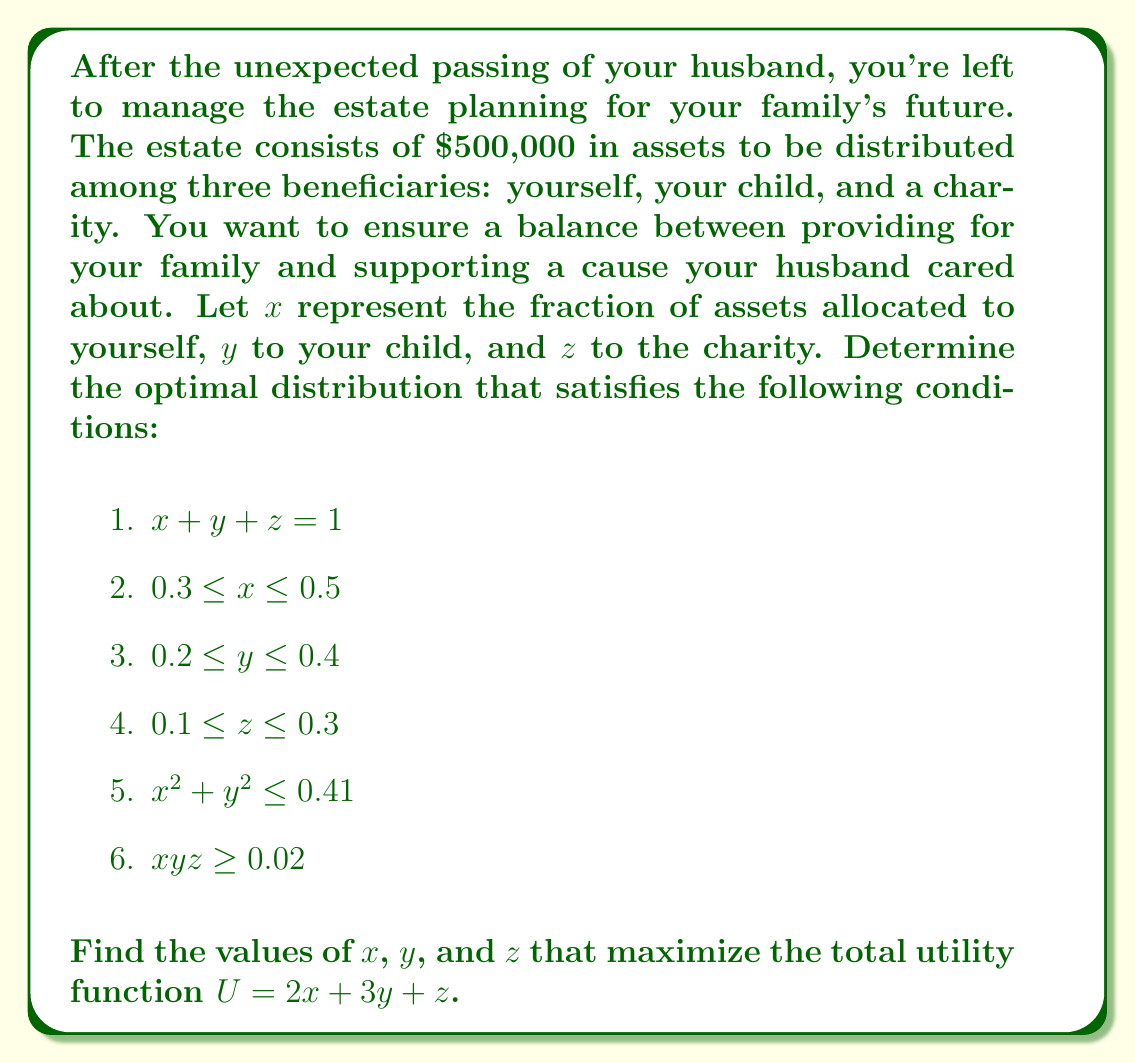Could you help me with this problem? To solve this problem, we'll use the method of constrained optimization with polynomial inequalities:

1) First, we note that the objective function to maximize is $U = 2x + 3y + z$.

2) The constraints form a feasible region in 3D space. We need to find the point in this region that maximizes $U$.

3) The constraint $x + y + z = 1$ allows us to eliminate one variable. Let's express $z$ in terms of $x$ and $y$:

   $z = 1 - x - y$

4) Substituting this into the objective function:

   $U = 2x + 3y + (1 - x - y) = x + 2y + 1$

5) Now we have a 2D optimization problem. The remaining constraints are:

   $0.3 \leq x \leq 0.5$
   $0.2 \leq y \leq 0.4$
   $0.1 \leq 1 - x - y \leq 0.3$
   $x^2 + y^2 \leq 0.41$
   $xy(1-x-y) \geq 0.02$

6) The maximum of $U = x + 2y + 1$ will occur at one of the corners of the feasible region or where the gradient of $U$ is perpendicular to a constraint boundary.

7) The gradient of $U$ is $\nabla U = (1, 2)$, which is constant. This means the maximum will occur at a corner point.

8) Checking the corner points that satisfy all constraints:

   $(0.5, 0.2, 0.3)$: $U = 1.9$
   $(0.5, 0.3, 0.2)$: $U = 2.1$
   $(0.4, 0.4, 0.2)$: $U = 2.2$

9) The maximum occurs at $(0.4, 0.4, 0.2)$, which satisfies all constraints.

Therefore, the optimal distribution is 40% to yourself, 40% to your child, and 20% to the charity.
Answer: $x = 0.4$, $y = 0.4$, $z = 0.2$ 